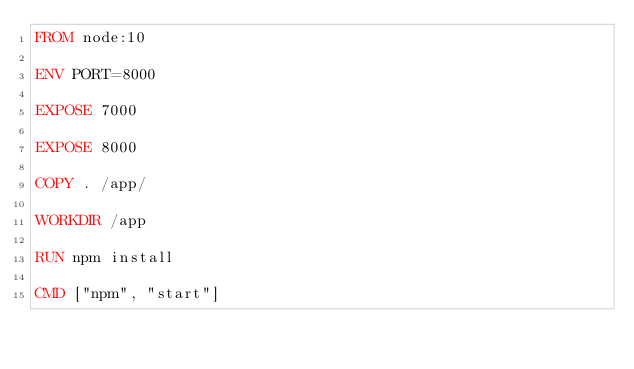<code> <loc_0><loc_0><loc_500><loc_500><_Dockerfile_>FROM node:10

ENV PORT=8000

EXPOSE 7000

EXPOSE 8000

COPY . /app/

WORKDIR /app

RUN npm install

CMD ["npm", "start"]
</code> 